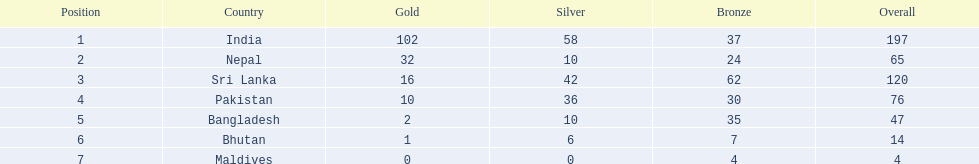What was the number of silver medals won by pakistan? 36. 